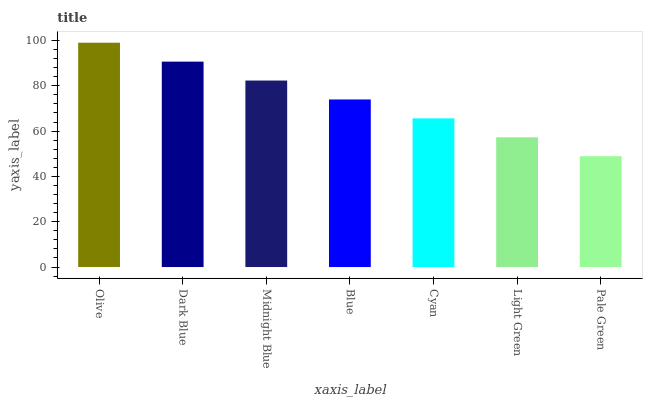Is Pale Green the minimum?
Answer yes or no. Yes. Is Olive the maximum?
Answer yes or no. Yes. Is Dark Blue the minimum?
Answer yes or no. No. Is Dark Blue the maximum?
Answer yes or no. No. Is Olive greater than Dark Blue?
Answer yes or no. Yes. Is Dark Blue less than Olive?
Answer yes or no. Yes. Is Dark Blue greater than Olive?
Answer yes or no. No. Is Olive less than Dark Blue?
Answer yes or no. No. Is Blue the high median?
Answer yes or no. Yes. Is Blue the low median?
Answer yes or no. Yes. Is Pale Green the high median?
Answer yes or no. No. Is Pale Green the low median?
Answer yes or no. No. 